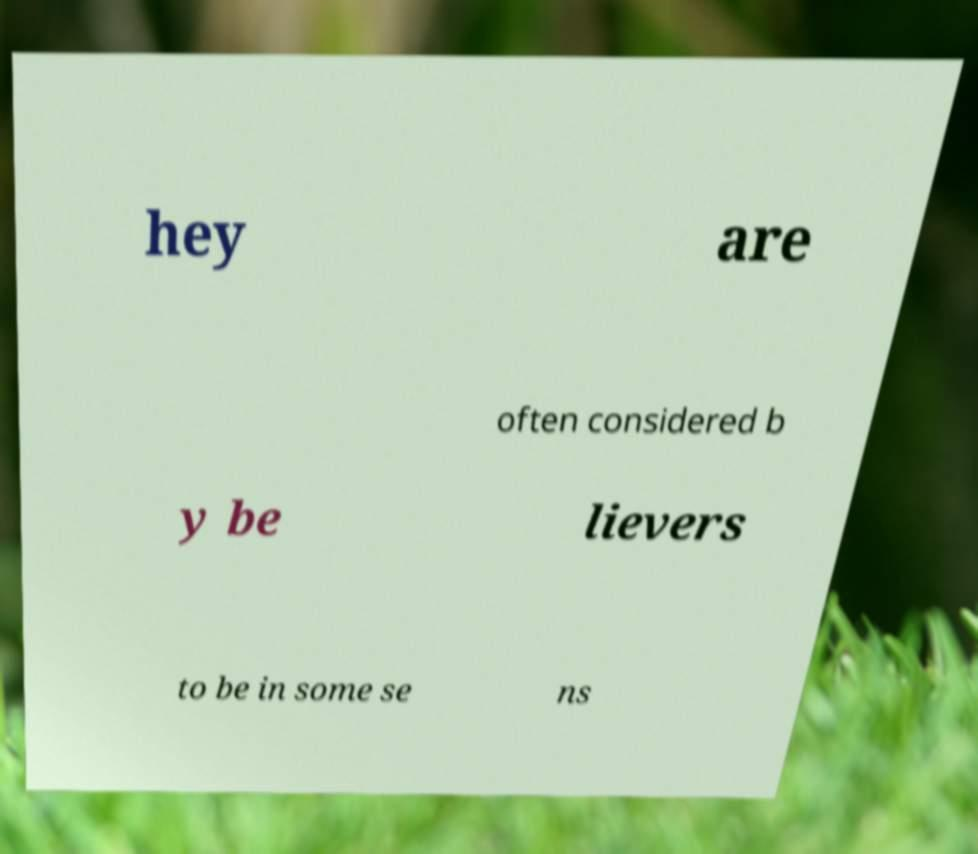Can you read and provide the text displayed in the image?This photo seems to have some interesting text. Can you extract and type it out for me? hey are often considered b y be lievers to be in some se ns 